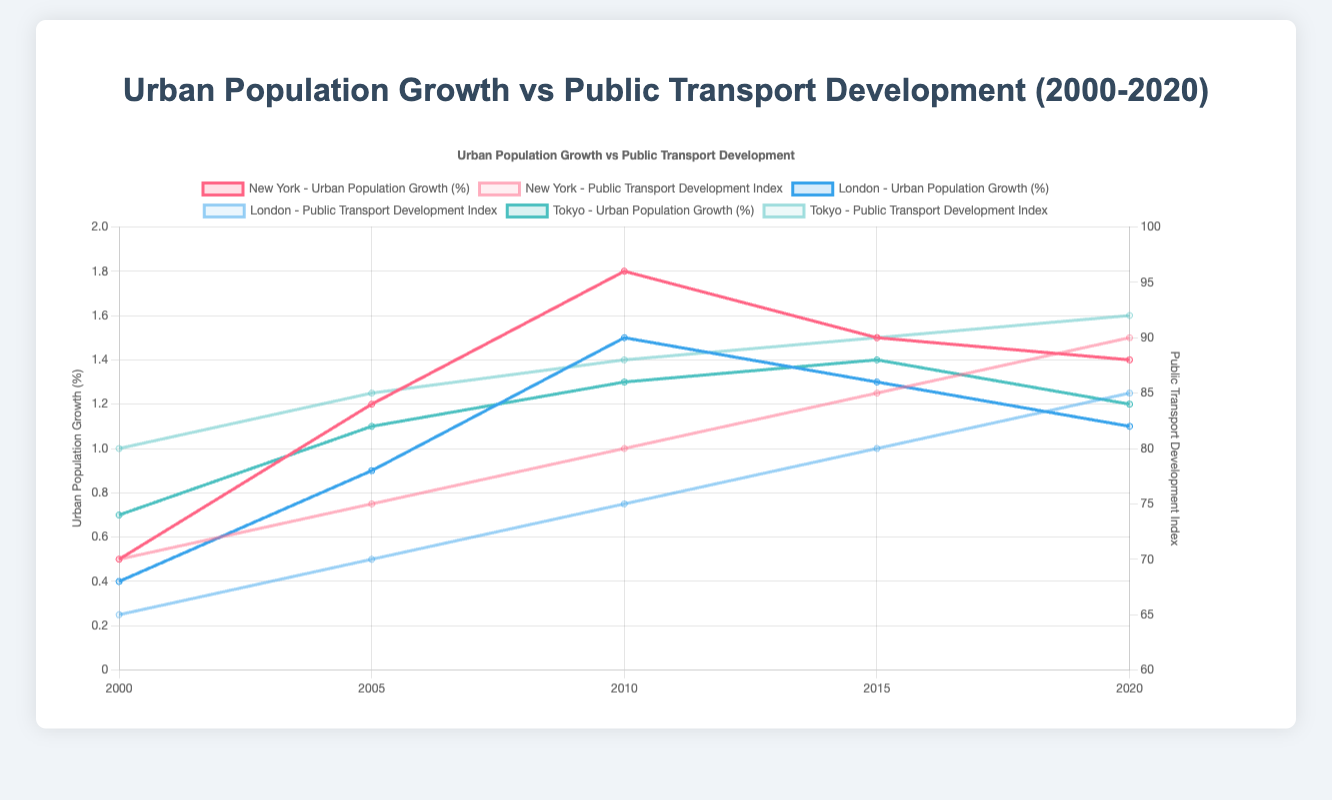1. Which city saw the highest urban population growth in 2010? To determine this, we look at the urban population growth percentage values for each city in 2010. New York has 1.8%, London has 1.5%, and Tokyo has 1.3%.
Answer: New York 2. How did the public transport development in New York change from 2000 to 2020? We observe the public transport development index for New York in 2000 and 2020. In 2000, it was 70, and in 2020, it was 90. The change is 90 - 70 = 20.
Answer: Increased by 20 3. Compare the public transport development index between London and Tokyo in 2005 In 2005, the public transport development index for London is 70, and for Tokyo, it is 85. 85 is greater than 70.
Answer: Tokyo is higher 4. What is the difference between urban population growth percentages of New York and Tokyo in 2015? For 2015, the urban population growth percentage for New York is 1.5%, and for Tokyo, it is 1.4%. The difference is 1.5% - 1.4% = 0.1%.
Answer: 0.1% 5. Which city had the smallest increase in urban population growth percentage from 2000 to 2005? We calculate the change for each city: New York (1.2% - 0.5% = 0.7%), London (0.9% - 0.4% = 0.5%), Tokyo (1.1% - 0.7% = 0.4%). Tokyo had the smallest increase.
Answer: Tokyo 6. What was the average public transport development index across all cities in 2020? In 2020, the public transport development index values are: New York (90), London (85), Tokyo (92). The average is (90 + 85 + 92) / 3 = 89.
Answer: 89 7. Between 2010 and 2015, which city experienced a decrease in urban population growth percentage? We check the urban population growth percentages for 2010 and 2015. Only New York decreased from 1.8% in 2010 to 1.5% in 2015.
Answer: New York 8. By how much did the urban population growth percentage in London increase from 2005 to 2010? In 2005, the urban population growth percentage in London was 0.9%. In 2010, it was 1.5%. The increase is 1.5% - 0.9% = 0.6%.
Answer: 0.6% 9. What is the trend of public transport development index in Tokyo from 2000 to 2020? Evaluating Tokyo's public transport development index: 2000 (80), 2005 (85), 2010 (88), 2015 (90), 2020 (92). This shows a consistent upward trend.
Answer: Increasing 10. Which city showed the same urban population growth percentage in consecutive time periods, and in which years? We compare consecutive urban population growth percentages for each city. London showed the same percentage of 1.1% in both 2015 and 2020.
Answer: London, 2015-2020 